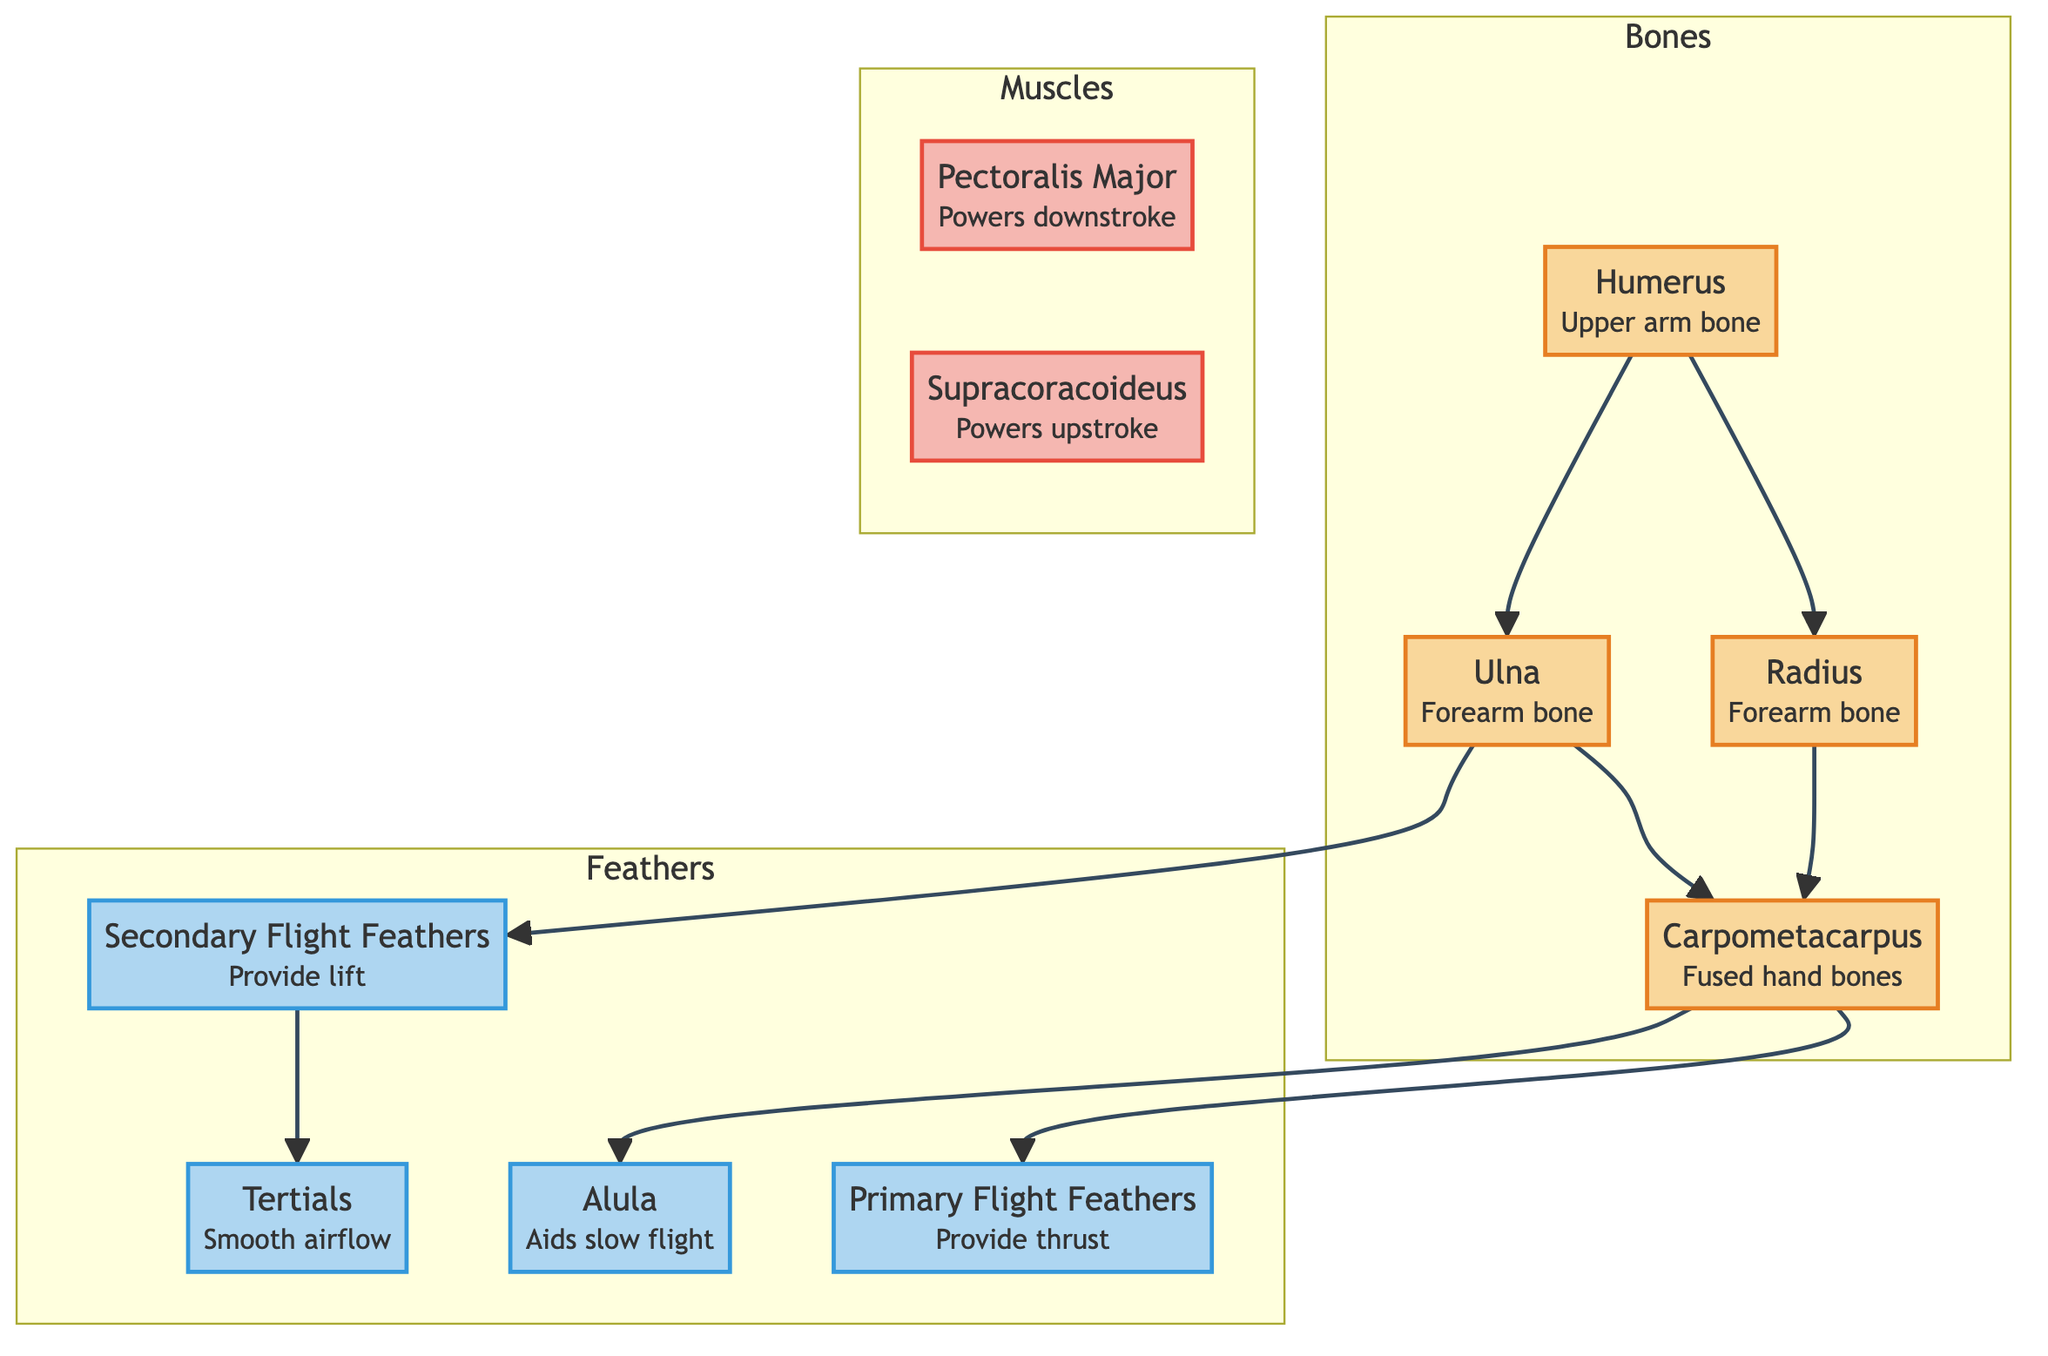What is the upper arm bone in a bird's wing? The diagram labels the humerus as the upper arm bone, making it clear that this is the specified bone in the wing's anatomy.
Answer: Humerus How many types of flight feathers are listed in the diagram? The diagram categorizes the feathers into three distinct types: primary, secondary, and tertials, totaling three types overall.
Answer: 3 Which muscle powers the downstroke of a bird's wing? According to the diagram, the pectoralis major is identified as the muscle responsible for powering the downstroke, which is crucial for flight.
Answer: Pectoralis Major What do the primary flight feathers provide? The diagram specifies that primary flight feathers provide thrust, indicating their role in propulsion during flight.
Answer: Thrust What bone connects the radius and ulna in the diagram? The diagram shows that the humerus connects to both the radius and ulna, establishing its position as the primary bone that links these forearm bones in the wing structure.
Answer: Humerus How do secondary flight feathers contribute to a bird's flight? The diagram states that secondary flight feathers provide lift, meaning they play a significant role in enabling the bird to rise and maintain altitude during flight.
Answer: Lift What small structure aids slow flight according to the diagram? The diagram identifies the alula as the small structure that aids slow flight, highlighting its importance in flight maneuverability and control.
Answer: Alula Which muscle is responsible for the upstroke of a bird's wing? The supracoracoideus is labeled in the diagram as the muscle that powers the upstroke, which is essential for the bird to retract its wings during flight.
Answer: Supracoracoideus What connects the ulna to the secondary flight feathers? The diagram illustrates that the ulna connects directly to the secondary flight feathers, indicating the structural relationship that allows these feathers to function effectively during flight.
Answer: Secondary Flight Feathers 